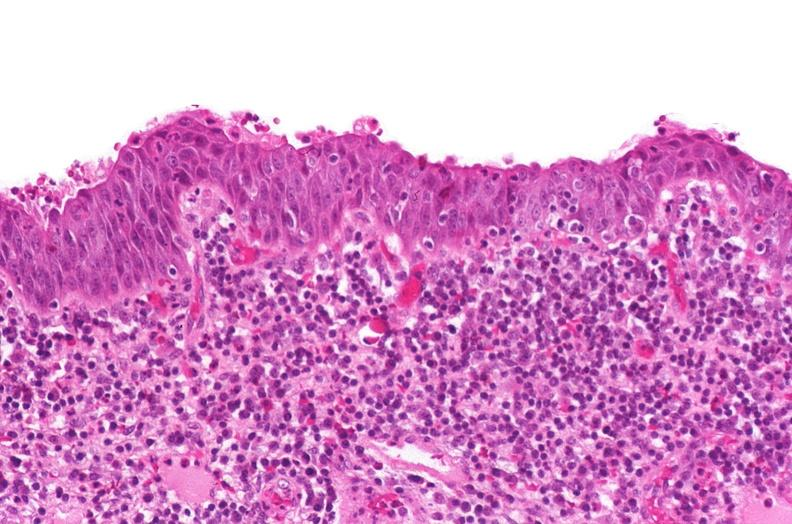does decubitus ulcer show renal pelvis, squamous metaplasia due to chronic urolithiasis?
Answer the question using a single word or phrase. No 